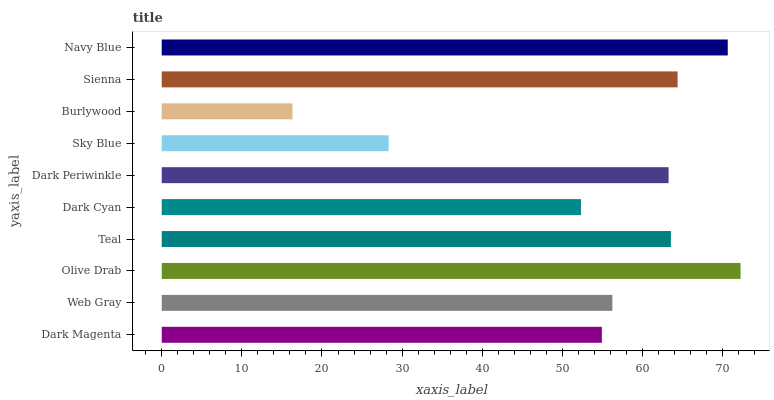Is Burlywood the minimum?
Answer yes or no. Yes. Is Olive Drab the maximum?
Answer yes or no. Yes. Is Web Gray the minimum?
Answer yes or no. No. Is Web Gray the maximum?
Answer yes or no. No. Is Web Gray greater than Dark Magenta?
Answer yes or no. Yes. Is Dark Magenta less than Web Gray?
Answer yes or no. Yes. Is Dark Magenta greater than Web Gray?
Answer yes or no. No. Is Web Gray less than Dark Magenta?
Answer yes or no. No. Is Dark Periwinkle the high median?
Answer yes or no. Yes. Is Web Gray the low median?
Answer yes or no. Yes. Is Olive Drab the high median?
Answer yes or no. No. Is Teal the low median?
Answer yes or no. No. 